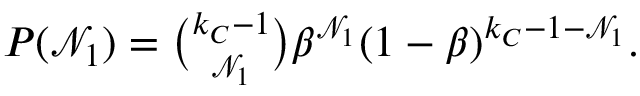Convert formula to latex. <formula><loc_0><loc_0><loc_500><loc_500>\begin{array} { r } { P ( \mathcal { N } _ { 1 } ) = \binom { k _ { C } - 1 } { \mathcal { N } _ { 1 } } \beta ^ { \mathcal { N } _ { 1 } } ( 1 - \beta ) ^ { k _ { C } - 1 - \mathcal { N } _ { 1 } } . } \end{array}</formula> 